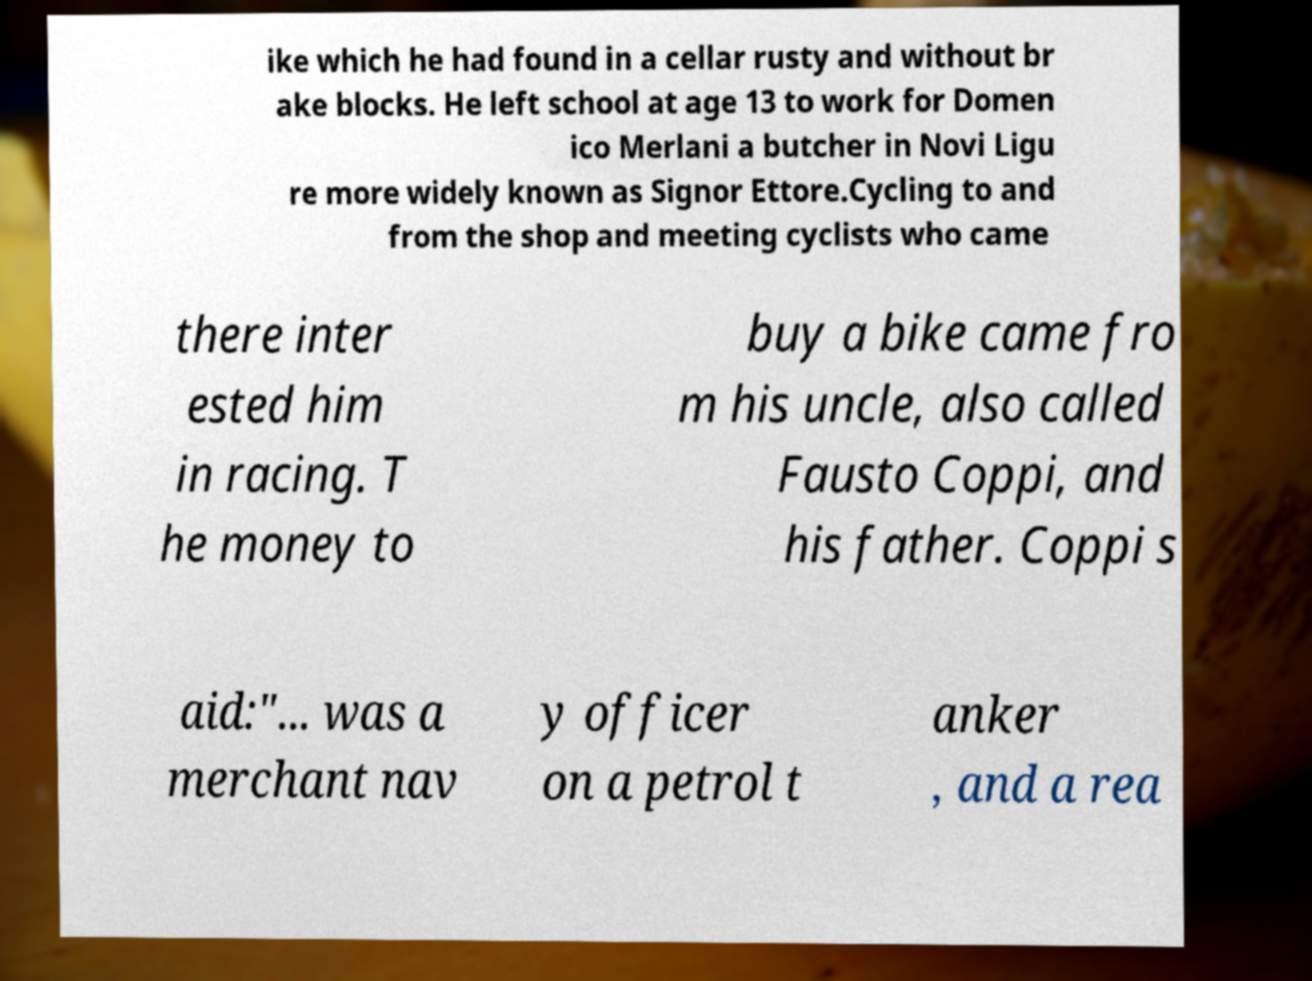For documentation purposes, I need the text within this image transcribed. Could you provide that? ike which he had found in a cellar rusty and without br ake blocks. He left school at age 13 to work for Domen ico Merlani a butcher in Novi Ligu re more widely known as Signor Ettore.Cycling to and from the shop and meeting cyclists who came there inter ested him in racing. T he money to buy a bike came fro m his uncle, also called Fausto Coppi, and his father. Coppi s aid:"... was a merchant nav y officer on a petrol t anker , and a rea 